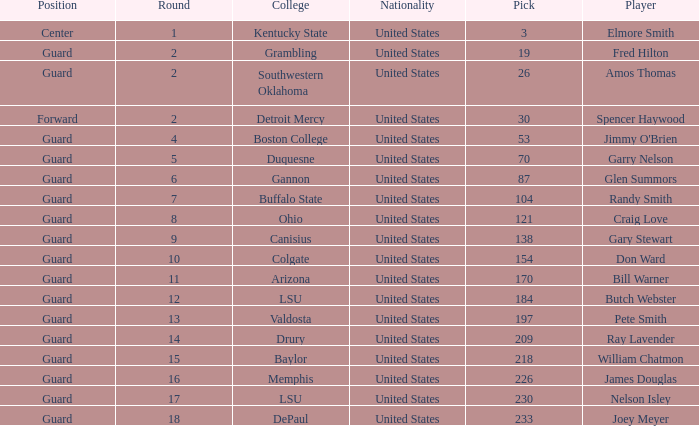WHAT IS THE NATIONALITY FOR SOUTHWESTERN OKLAHOMA? United States. 